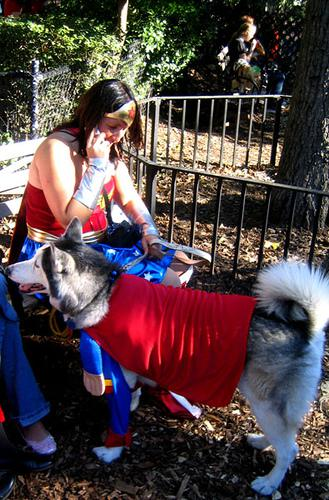Question: what costume is the woman wearing?
Choices:
A. Cinderella.
B. Wonder woman.
C. Cat woman.
D. Cleopatra.
Answer with the letter. Answer: B Question: where are the people at?
Choices:
A. Fair.
B. Concert.
C. Game.
D. Park.
Answer with the letter. Answer: D Question: how many people are there?
Choices:
A. 2.
B. 1.
C. 3.
D. 4.
Answer with the letter. Answer: A Question: who is with the dog?
Choices:
A. Man.
B. Girl.
C. Lady.
D. Dog walker.
Answer with the letter. Answer: C Question: where is the fence?
Choices:
A. On outside of the house.
B. Surrounding tree.
C. Where the horses are enclosed.
D. Near the flowers.
Answer with the letter. Answer: B 